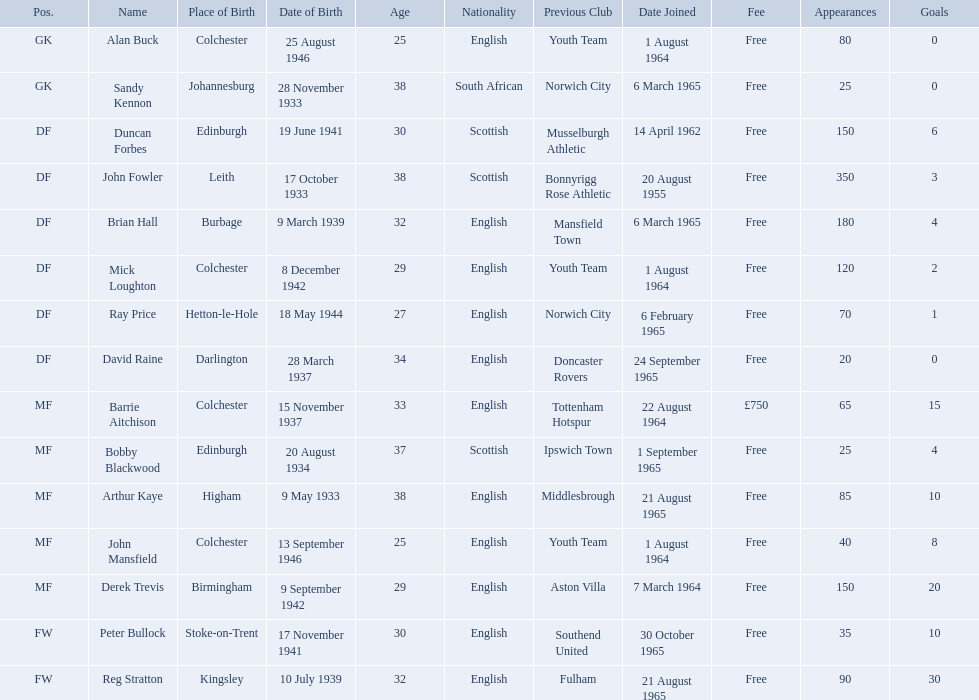When did each player join? 1 August 1964, 6 March 1965, 14 April 1962, 20 August 1955, 6 March 1965, 1 August 1964, 6 February 1965, 24 September 1965, 22 August 1964, 1 September 1965, 21 August 1965, 1 August 1964, 7 March 1964, 30 October 1965, 21 August 1965. And of those, which is the earliest join date? 20 August 1955. 